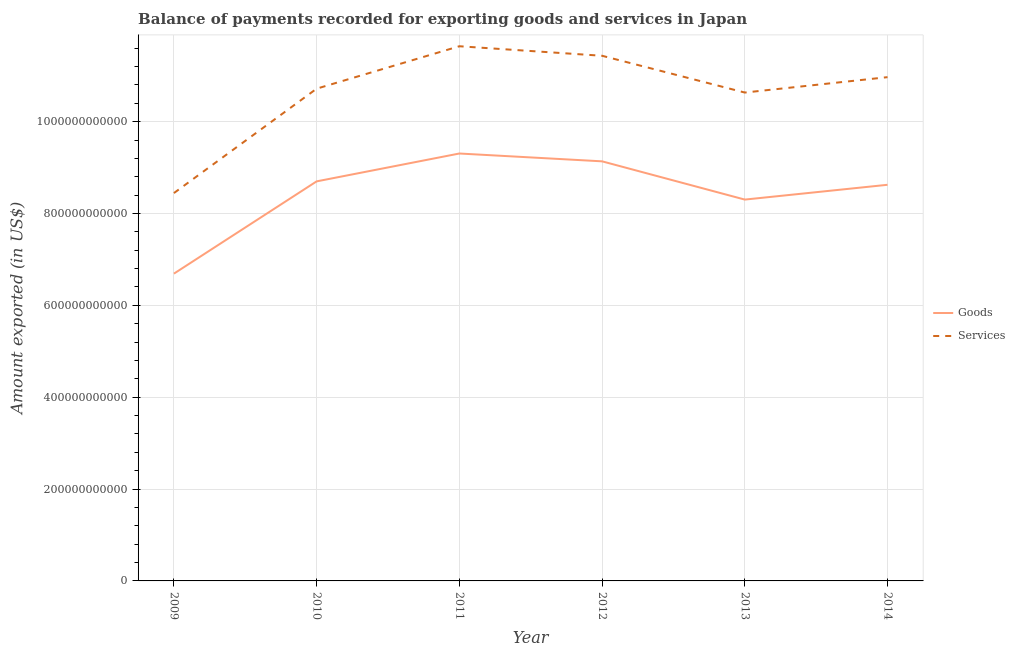What is the amount of goods exported in 2012?
Your response must be concise. 9.14e+11. Across all years, what is the maximum amount of services exported?
Your response must be concise. 1.16e+12. Across all years, what is the minimum amount of services exported?
Your answer should be very brief. 8.45e+11. In which year was the amount of services exported minimum?
Provide a succinct answer. 2009. What is the total amount of goods exported in the graph?
Provide a succinct answer. 5.08e+12. What is the difference between the amount of services exported in 2010 and that in 2011?
Your response must be concise. -9.24e+1. What is the difference between the amount of services exported in 2014 and the amount of goods exported in 2010?
Give a very brief answer. 2.27e+11. What is the average amount of goods exported per year?
Ensure brevity in your answer.  8.46e+11. In the year 2012, what is the difference between the amount of services exported and amount of goods exported?
Make the answer very short. 2.30e+11. In how many years, is the amount of goods exported greater than 80000000000 US$?
Give a very brief answer. 6. What is the ratio of the amount of goods exported in 2010 to that in 2012?
Provide a short and direct response. 0.95. Is the amount of goods exported in 2009 less than that in 2011?
Your answer should be compact. Yes. What is the difference between the highest and the second highest amount of services exported?
Keep it short and to the point. 2.07e+1. What is the difference between the highest and the lowest amount of services exported?
Provide a succinct answer. 3.20e+11. Does the amount of goods exported monotonically increase over the years?
Your answer should be very brief. No. Is the amount of services exported strictly greater than the amount of goods exported over the years?
Give a very brief answer. Yes. Is the amount of services exported strictly less than the amount of goods exported over the years?
Offer a very short reply. No. How many years are there in the graph?
Keep it short and to the point. 6. What is the difference between two consecutive major ticks on the Y-axis?
Provide a short and direct response. 2.00e+11. Are the values on the major ticks of Y-axis written in scientific E-notation?
Offer a very short reply. No. Where does the legend appear in the graph?
Give a very brief answer. Center right. How are the legend labels stacked?
Ensure brevity in your answer.  Vertical. What is the title of the graph?
Offer a very short reply. Balance of payments recorded for exporting goods and services in Japan. What is the label or title of the X-axis?
Make the answer very short. Year. What is the label or title of the Y-axis?
Provide a succinct answer. Amount exported (in US$). What is the Amount exported (in US$) of Goods in 2009?
Provide a short and direct response. 6.69e+11. What is the Amount exported (in US$) of Services in 2009?
Ensure brevity in your answer.  8.45e+11. What is the Amount exported (in US$) of Goods in 2010?
Make the answer very short. 8.70e+11. What is the Amount exported (in US$) of Services in 2010?
Provide a succinct answer. 1.07e+12. What is the Amount exported (in US$) of Goods in 2011?
Provide a succinct answer. 9.31e+11. What is the Amount exported (in US$) of Services in 2011?
Your response must be concise. 1.16e+12. What is the Amount exported (in US$) of Goods in 2012?
Your answer should be very brief. 9.14e+11. What is the Amount exported (in US$) in Services in 2012?
Give a very brief answer. 1.14e+12. What is the Amount exported (in US$) of Goods in 2013?
Keep it short and to the point. 8.30e+11. What is the Amount exported (in US$) of Services in 2013?
Make the answer very short. 1.06e+12. What is the Amount exported (in US$) of Goods in 2014?
Ensure brevity in your answer.  8.63e+11. What is the Amount exported (in US$) of Services in 2014?
Offer a terse response. 1.10e+12. Across all years, what is the maximum Amount exported (in US$) of Goods?
Provide a short and direct response. 9.31e+11. Across all years, what is the maximum Amount exported (in US$) in Services?
Ensure brevity in your answer.  1.16e+12. Across all years, what is the minimum Amount exported (in US$) in Goods?
Your answer should be very brief. 6.69e+11. Across all years, what is the minimum Amount exported (in US$) in Services?
Your answer should be compact. 8.45e+11. What is the total Amount exported (in US$) of Goods in the graph?
Offer a terse response. 5.08e+12. What is the total Amount exported (in US$) in Services in the graph?
Your response must be concise. 6.38e+12. What is the difference between the Amount exported (in US$) of Goods in 2009 and that in 2010?
Your answer should be very brief. -2.01e+11. What is the difference between the Amount exported (in US$) of Services in 2009 and that in 2010?
Make the answer very short. -2.27e+11. What is the difference between the Amount exported (in US$) of Goods in 2009 and that in 2011?
Offer a very short reply. -2.62e+11. What is the difference between the Amount exported (in US$) of Services in 2009 and that in 2011?
Your response must be concise. -3.20e+11. What is the difference between the Amount exported (in US$) of Goods in 2009 and that in 2012?
Make the answer very short. -2.45e+11. What is the difference between the Amount exported (in US$) of Services in 2009 and that in 2012?
Offer a terse response. -2.99e+11. What is the difference between the Amount exported (in US$) of Goods in 2009 and that in 2013?
Offer a very short reply. -1.61e+11. What is the difference between the Amount exported (in US$) in Services in 2009 and that in 2013?
Offer a very short reply. -2.19e+11. What is the difference between the Amount exported (in US$) of Goods in 2009 and that in 2014?
Provide a succinct answer. -1.93e+11. What is the difference between the Amount exported (in US$) in Services in 2009 and that in 2014?
Offer a very short reply. -2.52e+11. What is the difference between the Amount exported (in US$) of Goods in 2010 and that in 2011?
Provide a succinct answer. -6.07e+1. What is the difference between the Amount exported (in US$) in Services in 2010 and that in 2011?
Offer a very short reply. -9.24e+1. What is the difference between the Amount exported (in US$) of Goods in 2010 and that in 2012?
Give a very brief answer. -4.36e+1. What is the difference between the Amount exported (in US$) in Services in 2010 and that in 2012?
Give a very brief answer. -7.16e+1. What is the difference between the Amount exported (in US$) of Goods in 2010 and that in 2013?
Provide a short and direct response. 3.97e+1. What is the difference between the Amount exported (in US$) in Services in 2010 and that in 2013?
Offer a terse response. 8.42e+09. What is the difference between the Amount exported (in US$) in Goods in 2010 and that in 2014?
Offer a very short reply. 7.46e+09. What is the difference between the Amount exported (in US$) of Services in 2010 and that in 2014?
Give a very brief answer. -2.51e+1. What is the difference between the Amount exported (in US$) in Goods in 2011 and that in 2012?
Your response must be concise. 1.70e+1. What is the difference between the Amount exported (in US$) of Services in 2011 and that in 2012?
Keep it short and to the point. 2.07e+1. What is the difference between the Amount exported (in US$) in Goods in 2011 and that in 2013?
Your answer should be compact. 1.00e+11. What is the difference between the Amount exported (in US$) in Services in 2011 and that in 2013?
Make the answer very short. 1.01e+11. What is the difference between the Amount exported (in US$) of Goods in 2011 and that in 2014?
Offer a terse response. 6.81e+1. What is the difference between the Amount exported (in US$) of Services in 2011 and that in 2014?
Your answer should be very brief. 6.73e+1. What is the difference between the Amount exported (in US$) in Goods in 2012 and that in 2013?
Offer a very short reply. 8.33e+1. What is the difference between the Amount exported (in US$) of Services in 2012 and that in 2013?
Your answer should be compact. 8.01e+1. What is the difference between the Amount exported (in US$) in Goods in 2012 and that in 2014?
Offer a terse response. 5.11e+1. What is the difference between the Amount exported (in US$) of Services in 2012 and that in 2014?
Ensure brevity in your answer.  4.66e+1. What is the difference between the Amount exported (in US$) of Goods in 2013 and that in 2014?
Offer a terse response. -3.22e+1. What is the difference between the Amount exported (in US$) of Services in 2013 and that in 2014?
Give a very brief answer. -3.35e+1. What is the difference between the Amount exported (in US$) of Goods in 2009 and the Amount exported (in US$) of Services in 2010?
Offer a terse response. -4.03e+11. What is the difference between the Amount exported (in US$) in Goods in 2009 and the Amount exported (in US$) in Services in 2011?
Your answer should be very brief. -4.95e+11. What is the difference between the Amount exported (in US$) of Goods in 2009 and the Amount exported (in US$) of Services in 2012?
Offer a very short reply. -4.74e+11. What is the difference between the Amount exported (in US$) in Goods in 2009 and the Amount exported (in US$) in Services in 2013?
Keep it short and to the point. -3.94e+11. What is the difference between the Amount exported (in US$) in Goods in 2009 and the Amount exported (in US$) in Services in 2014?
Your answer should be very brief. -4.28e+11. What is the difference between the Amount exported (in US$) in Goods in 2010 and the Amount exported (in US$) in Services in 2011?
Keep it short and to the point. -2.94e+11. What is the difference between the Amount exported (in US$) of Goods in 2010 and the Amount exported (in US$) of Services in 2012?
Offer a very short reply. -2.73e+11. What is the difference between the Amount exported (in US$) in Goods in 2010 and the Amount exported (in US$) in Services in 2013?
Provide a short and direct response. -1.93e+11. What is the difference between the Amount exported (in US$) of Goods in 2010 and the Amount exported (in US$) of Services in 2014?
Give a very brief answer. -2.27e+11. What is the difference between the Amount exported (in US$) of Goods in 2011 and the Amount exported (in US$) of Services in 2012?
Ensure brevity in your answer.  -2.13e+11. What is the difference between the Amount exported (in US$) of Goods in 2011 and the Amount exported (in US$) of Services in 2013?
Your answer should be very brief. -1.33e+11. What is the difference between the Amount exported (in US$) of Goods in 2011 and the Amount exported (in US$) of Services in 2014?
Provide a short and direct response. -1.66e+11. What is the difference between the Amount exported (in US$) in Goods in 2012 and the Amount exported (in US$) in Services in 2013?
Make the answer very short. -1.50e+11. What is the difference between the Amount exported (in US$) in Goods in 2012 and the Amount exported (in US$) in Services in 2014?
Give a very brief answer. -1.83e+11. What is the difference between the Amount exported (in US$) in Goods in 2013 and the Amount exported (in US$) in Services in 2014?
Your response must be concise. -2.67e+11. What is the average Amount exported (in US$) in Goods per year?
Offer a terse response. 8.46e+11. What is the average Amount exported (in US$) in Services per year?
Provide a short and direct response. 1.06e+12. In the year 2009, what is the difference between the Amount exported (in US$) of Goods and Amount exported (in US$) of Services?
Your answer should be very brief. -1.75e+11. In the year 2010, what is the difference between the Amount exported (in US$) in Goods and Amount exported (in US$) in Services?
Your answer should be compact. -2.02e+11. In the year 2011, what is the difference between the Amount exported (in US$) in Goods and Amount exported (in US$) in Services?
Your answer should be very brief. -2.34e+11. In the year 2012, what is the difference between the Amount exported (in US$) of Goods and Amount exported (in US$) of Services?
Ensure brevity in your answer.  -2.30e+11. In the year 2013, what is the difference between the Amount exported (in US$) in Goods and Amount exported (in US$) in Services?
Ensure brevity in your answer.  -2.33e+11. In the year 2014, what is the difference between the Amount exported (in US$) in Goods and Amount exported (in US$) in Services?
Your answer should be compact. -2.34e+11. What is the ratio of the Amount exported (in US$) in Goods in 2009 to that in 2010?
Your response must be concise. 0.77. What is the ratio of the Amount exported (in US$) of Services in 2009 to that in 2010?
Ensure brevity in your answer.  0.79. What is the ratio of the Amount exported (in US$) of Goods in 2009 to that in 2011?
Your answer should be compact. 0.72. What is the ratio of the Amount exported (in US$) in Services in 2009 to that in 2011?
Your response must be concise. 0.73. What is the ratio of the Amount exported (in US$) in Goods in 2009 to that in 2012?
Your answer should be compact. 0.73. What is the ratio of the Amount exported (in US$) of Services in 2009 to that in 2012?
Your answer should be compact. 0.74. What is the ratio of the Amount exported (in US$) of Goods in 2009 to that in 2013?
Provide a short and direct response. 0.81. What is the ratio of the Amount exported (in US$) of Services in 2009 to that in 2013?
Offer a terse response. 0.79. What is the ratio of the Amount exported (in US$) in Goods in 2009 to that in 2014?
Provide a short and direct response. 0.78. What is the ratio of the Amount exported (in US$) in Services in 2009 to that in 2014?
Offer a very short reply. 0.77. What is the ratio of the Amount exported (in US$) in Goods in 2010 to that in 2011?
Keep it short and to the point. 0.93. What is the ratio of the Amount exported (in US$) in Services in 2010 to that in 2011?
Keep it short and to the point. 0.92. What is the ratio of the Amount exported (in US$) of Goods in 2010 to that in 2012?
Keep it short and to the point. 0.95. What is the ratio of the Amount exported (in US$) in Services in 2010 to that in 2012?
Offer a terse response. 0.94. What is the ratio of the Amount exported (in US$) in Goods in 2010 to that in 2013?
Provide a succinct answer. 1.05. What is the ratio of the Amount exported (in US$) of Services in 2010 to that in 2013?
Give a very brief answer. 1.01. What is the ratio of the Amount exported (in US$) in Goods in 2010 to that in 2014?
Provide a short and direct response. 1.01. What is the ratio of the Amount exported (in US$) of Services in 2010 to that in 2014?
Provide a succinct answer. 0.98. What is the ratio of the Amount exported (in US$) of Goods in 2011 to that in 2012?
Keep it short and to the point. 1.02. What is the ratio of the Amount exported (in US$) in Services in 2011 to that in 2012?
Your answer should be very brief. 1.02. What is the ratio of the Amount exported (in US$) of Goods in 2011 to that in 2013?
Your answer should be compact. 1.12. What is the ratio of the Amount exported (in US$) of Services in 2011 to that in 2013?
Offer a very short reply. 1.09. What is the ratio of the Amount exported (in US$) of Goods in 2011 to that in 2014?
Your response must be concise. 1.08. What is the ratio of the Amount exported (in US$) in Services in 2011 to that in 2014?
Offer a terse response. 1.06. What is the ratio of the Amount exported (in US$) in Goods in 2012 to that in 2013?
Provide a succinct answer. 1.1. What is the ratio of the Amount exported (in US$) in Services in 2012 to that in 2013?
Offer a very short reply. 1.08. What is the ratio of the Amount exported (in US$) in Goods in 2012 to that in 2014?
Ensure brevity in your answer.  1.06. What is the ratio of the Amount exported (in US$) in Services in 2012 to that in 2014?
Your response must be concise. 1.04. What is the ratio of the Amount exported (in US$) in Goods in 2013 to that in 2014?
Your answer should be compact. 0.96. What is the ratio of the Amount exported (in US$) in Services in 2013 to that in 2014?
Keep it short and to the point. 0.97. What is the difference between the highest and the second highest Amount exported (in US$) of Goods?
Offer a terse response. 1.70e+1. What is the difference between the highest and the second highest Amount exported (in US$) of Services?
Your answer should be compact. 2.07e+1. What is the difference between the highest and the lowest Amount exported (in US$) of Goods?
Offer a terse response. 2.62e+11. What is the difference between the highest and the lowest Amount exported (in US$) of Services?
Keep it short and to the point. 3.20e+11. 